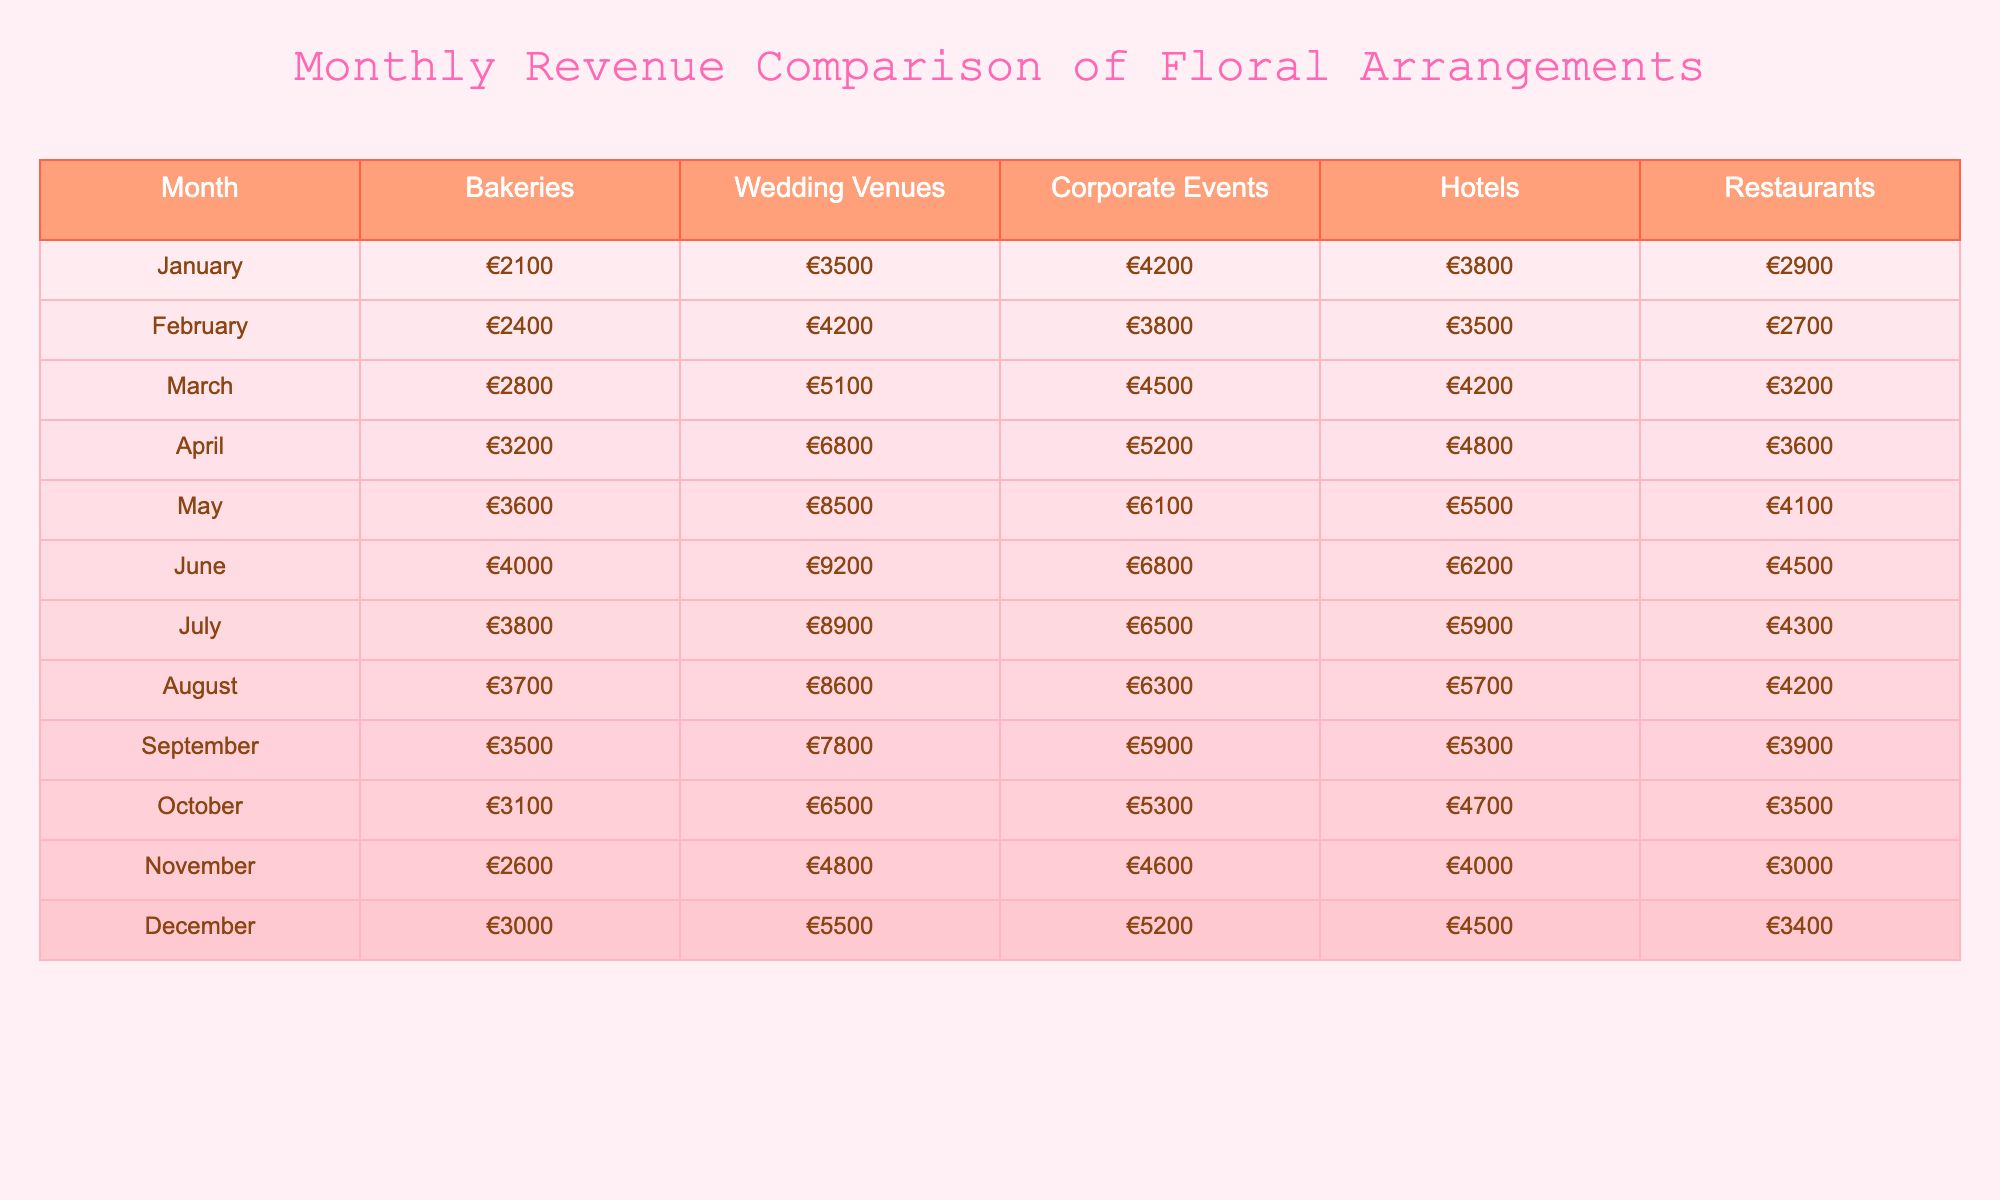What was the revenue from bakeries in May? In May, the revenue from bakeries is listed as €3600 in the table.
Answer: €3600 Which month had the highest revenue for wedding venues? The table shows that May has the highest revenue for wedding venues at €8500.
Answer: May What is the difference in revenue from bakeries between March and April? In March, the revenue from bakeries is €2800, and in April, it is €3200. The difference is €3200 - €2800 = €400.
Answer: €400 What is the average revenue for corporate events over the year? Adding the revenues for corporate events: €4200 + €3800 + €4500 + €5200 + €6100 + €6800 + €6500 + €6300 + €5900 + €5300 + €4600 + €5200 = €68,100. Dividing this by 12 months gives an average of €68,100 / 12 = €5,675.
Answer: €5,675 Was there any month when the revenue from bakeries was less than €3000? Looking at the table, the only months where bakeries had revenue less than €3000 are November (€2600) and December (€3000). Thus, the answer is yes.
Answer: Yes What was the total revenue from hotels in the third quarter (July, August, September)? The revenues from hotels for these months are July (€5900), August (€5700), and September (€5300). Adding these values gives €5900 + €5700 + €5300 = €16900.
Answer: €16,900 Which type of venue consistently had the highest revenue throughout the year? By examining the table, wedding venues consistently have the highest revenue in every month compared to the other types, indicating they are the most profitable venue.
Answer: Wedding venues In which month did hotels see a revenue decrease compared to the previous month? The table shows that from June (€6200) to July (€5900), hotels had a revenue decrease.
Answer: July What was the total revenue from restaurants in December? In December, the revenue from restaurants is €3400 as stated in the table.
Answer: €3400 Which month has the smallest overall revenue across all venue types? By adding all venue revenues for each month, January has the smallest overall total of €2100 + €3500 + €4200 + €3800 + €2900 = €21,500.
Answer: January 